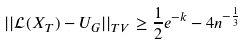Convert formula to latex. <formula><loc_0><loc_0><loc_500><loc_500>| | \mathcal { L } ( X _ { T } ) - U _ { G } | | _ { T V } \geq \frac { 1 } { 2 } e ^ { - k } - 4 n ^ { - \frac { 1 } { 3 } }</formula> 